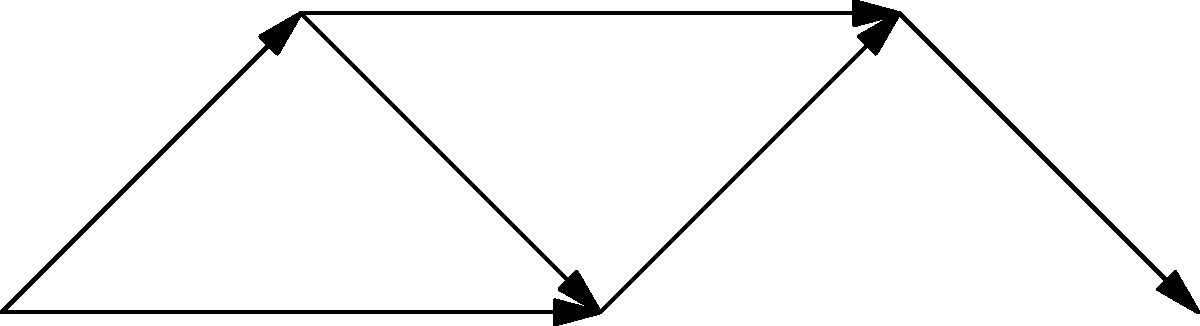In the water distribution network shown above, each node represents a distribution point, and the edges represent pipelines with their respective flow rates (in million gallons per day). What is the maximum flow rate that can reach point E, and which path(s) contribute to this maximum flow? To solve this problem, we need to analyze the network using the principles of maximum flow in a directed graph. Let's break it down step-by-step:

1. Identify all possible paths from A to E:
   Path 1: A → B → C → D → E
   Path 2: A → B → D → E
   Path 3: A → C → D → E

2. Calculate the flow for each path:
   Path 1: min(10, 8, 6, 4) = 4
   Path 2: min(10, 2, 4) = 2
   Path 3: min(2, 6, 4) = 2

3. The maximum flow will be the sum of the flows through all non-overlapping paths. We can use Path 1 and either Path 2 or Path 3, but not both, as they share edges.

4. Calculate the maximum flow:
   Max Flow = Flow(Path 1) + max(Flow(Path 2), Flow(Path 3))
            = 4 + max(2, 2)
            = 4 + 2 = 6

5. The paths contributing to this maximum flow are:
   - A → B → C → D → E (4 million gallons per day)
   - A → B → D → E (2 million gallons per day)
   or
   - A → B → C → D → E (4 million gallons per day)
   - A → C → D → E (2 million gallons per day)

Therefore, the maximum flow rate that can reach point E is 6 million gallons per day, achieved through a combination of two paths.
Answer: 6 million gallons per day, achieved through two paths: A→B→C→D→E and either A→B→D→E or A→C→D→E. 